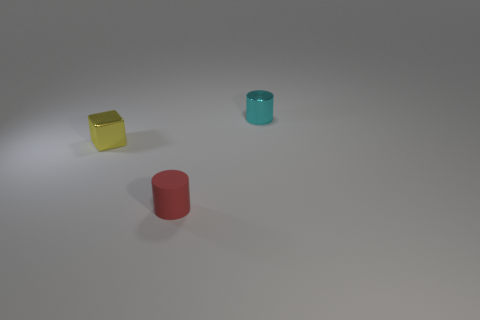What material do the objects in the image seem to be made of? The objects in the image appear to be made of a material with properties of plastic, given their smooth surfaces and the way light reflects off them. The matte texture suggests it's not a reflective, glossy plastic, but rather one that diffuses light softly. 